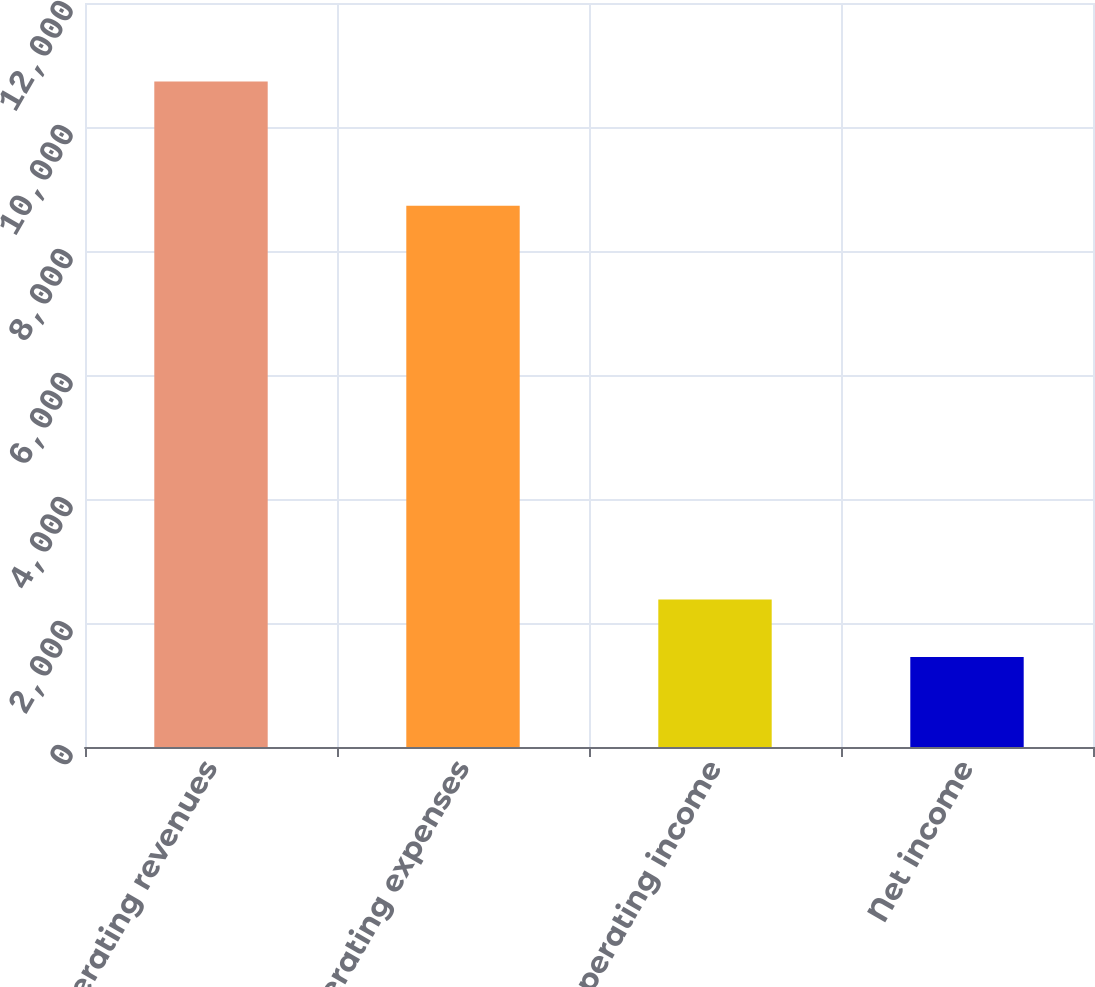Convert chart to OTSL. <chart><loc_0><loc_0><loc_500><loc_500><bar_chart><fcel>Operating revenues<fcel>Operating expenses<fcel>Operating income<fcel>Net income<nl><fcel>10733<fcel>8730<fcel>2378.3<fcel>1450<nl></chart> 